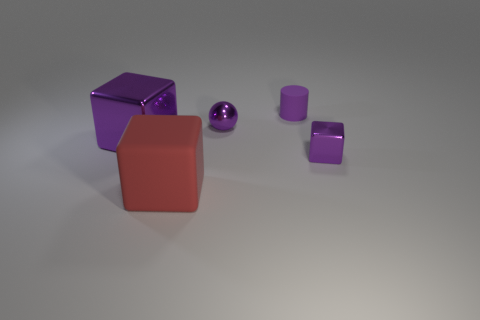There is a tiny metallic thing in front of the large shiny block; is its color the same as the tiny shiny object that is to the left of the matte cylinder?
Ensure brevity in your answer.  Yes. There is a matte cylinder to the left of the tiny purple cube; what is its size?
Give a very brief answer. Small. Is there a object that has the same material as the small purple ball?
Your response must be concise. Yes. Does the matte thing that is behind the small metal ball have the same color as the small metallic ball?
Your answer should be compact. Yes. Are there an equal number of purple metal cubes that are behind the purple cylinder and small purple cylinders?
Your answer should be compact. No. Are there any other large blocks of the same color as the rubber block?
Your answer should be compact. No. Is the matte block the same size as the purple matte cylinder?
Make the answer very short. No. What is the size of the rubber thing that is in front of the tiny cube to the right of the large red cube?
Ensure brevity in your answer.  Large. There is a object that is both behind the large purple cube and on the right side of the ball; how big is it?
Give a very brief answer. Small. What number of purple blocks are the same size as the purple cylinder?
Your answer should be compact. 1. 